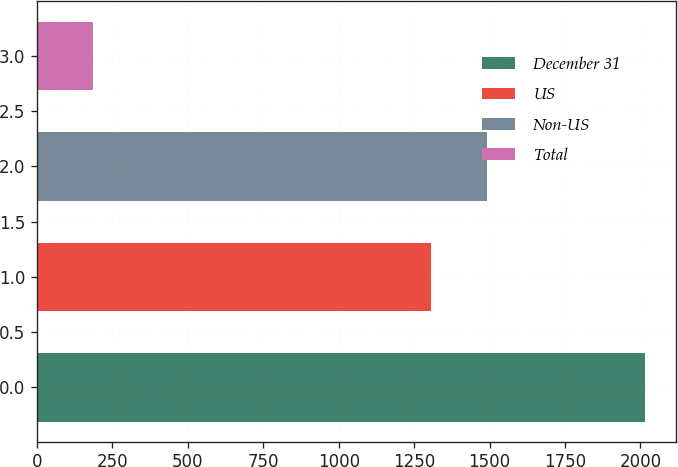Convert chart to OTSL. <chart><loc_0><loc_0><loc_500><loc_500><bar_chart><fcel>December 31<fcel>US<fcel>Non-US<fcel>Total<nl><fcel>2016<fcel>1305<fcel>1492<fcel>187<nl></chart> 